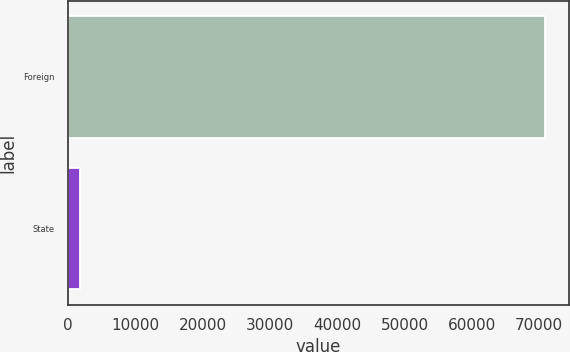Convert chart to OTSL. <chart><loc_0><loc_0><loc_500><loc_500><bar_chart><fcel>Foreign<fcel>State<nl><fcel>70882<fcel>1770<nl></chart> 